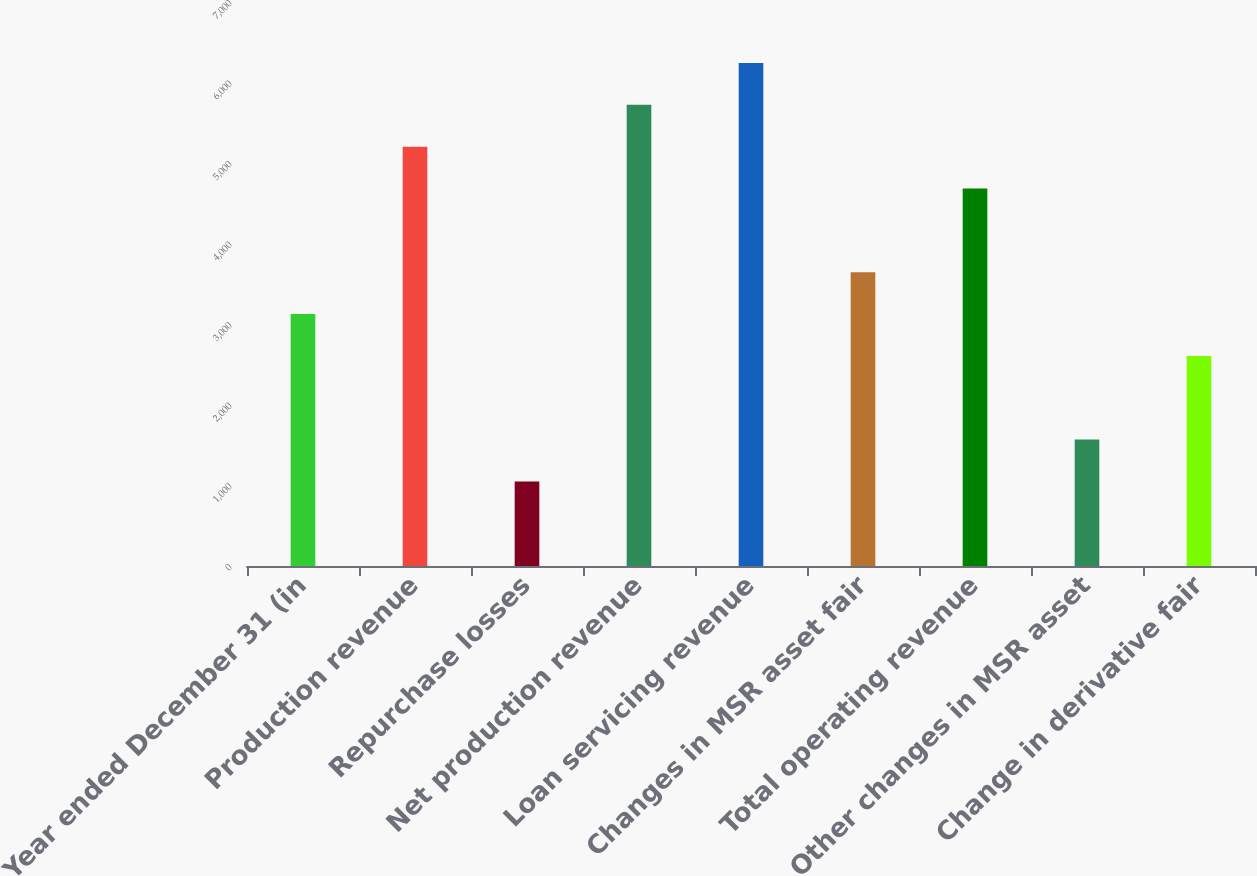<chart> <loc_0><loc_0><loc_500><loc_500><bar_chart><fcel>Year ended December 31 (in<fcel>Production revenue<fcel>Repurchase losses<fcel>Net production revenue<fcel>Loan servicing revenue<fcel>Changes in MSR asset fair<fcel>Total operating revenue<fcel>Other changes in MSR asset<fcel>Change in derivative fair<nl><fcel>3127<fcel>5205<fcel>1049<fcel>5724.5<fcel>6244<fcel>3646.5<fcel>4685.5<fcel>1568.5<fcel>2607.5<nl></chart> 